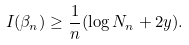<formula> <loc_0><loc_0><loc_500><loc_500>I ( \beta _ { n } ) \geq \frac { 1 } { n } ( \log N _ { n } + 2 y ) .</formula> 